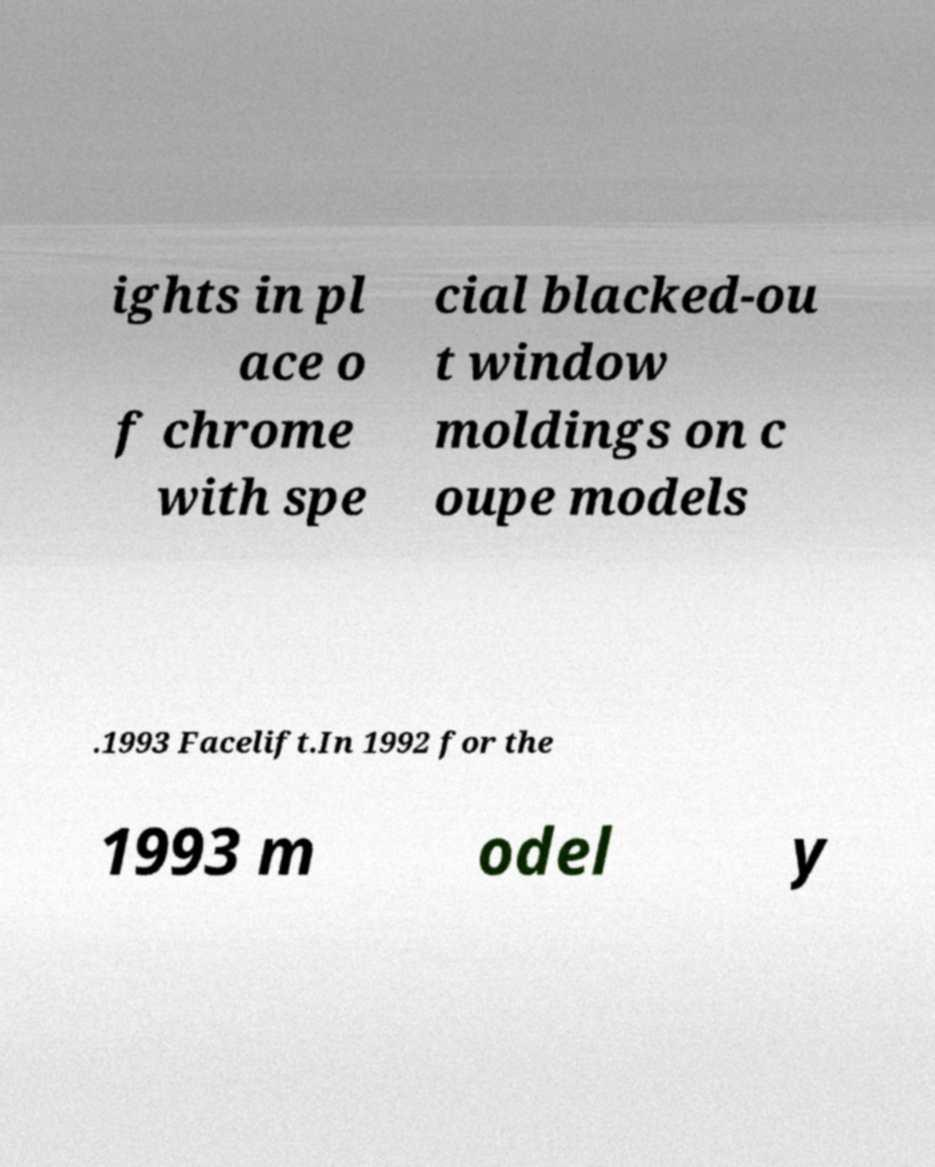Can you accurately transcribe the text from the provided image for me? ights in pl ace o f chrome with spe cial blacked-ou t window moldings on c oupe models .1993 Facelift.In 1992 for the 1993 m odel y 